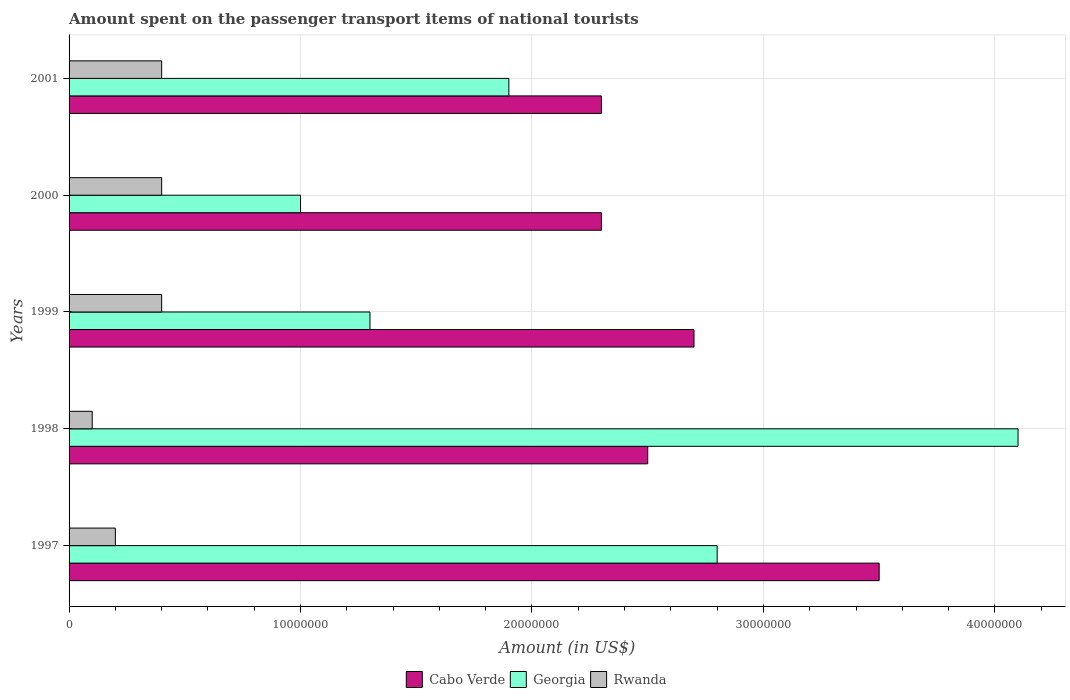Are the number of bars per tick equal to the number of legend labels?
Ensure brevity in your answer.  Yes. How many bars are there on the 4th tick from the top?
Keep it short and to the point. 3. What is the label of the 4th group of bars from the top?
Make the answer very short. 1998. In how many cases, is the number of bars for a given year not equal to the number of legend labels?
Your response must be concise. 0. What is the amount spent on the passenger transport items of national tourists in Cabo Verde in 2000?
Ensure brevity in your answer.  2.30e+07. Across all years, what is the maximum amount spent on the passenger transport items of national tourists in Rwanda?
Your response must be concise. 4.00e+06. Across all years, what is the minimum amount spent on the passenger transport items of national tourists in Georgia?
Provide a short and direct response. 1.00e+07. In which year was the amount spent on the passenger transport items of national tourists in Georgia maximum?
Your answer should be compact. 1998. In which year was the amount spent on the passenger transport items of national tourists in Rwanda minimum?
Keep it short and to the point. 1998. What is the total amount spent on the passenger transport items of national tourists in Georgia in the graph?
Your answer should be compact. 1.11e+08. What is the difference between the amount spent on the passenger transport items of national tourists in Rwanda in 1999 and that in 2001?
Offer a terse response. 0. What is the difference between the amount spent on the passenger transport items of national tourists in Cabo Verde in 2000 and the amount spent on the passenger transport items of national tourists in Georgia in 1998?
Provide a succinct answer. -1.80e+07. In the year 2000, what is the difference between the amount spent on the passenger transport items of national tourists in Georgia and amount spent on the passenger transport items of national tourists in Rwanda?
Give a very brief answer. 6.00e+06. What is the ratio of the amount spent on the passenger transport items of national tourists in Rwanda in 1997 to that in 2000?
Ensure brevity in your answer.  0.5. Is the amount spent on the passenger transport items of national tourists in Georgia in 1999 less than that in 2000?
Your response must be concise. No. Is the sum of the amount spent on the passenger transport items of national tourists in Cabo Verde in 1998 and 1999 greater than the maximum amount spent on the passenger transport items of national tourists in Georgia across all years?
Your answer should be compact. Yes. What does the 2nd bar from the top in 1997 represents?
Offer a very short reply. Georgia. What does the 1st bar from the bottom in 1997 represents?
Provide a short and direct response. Cabo Verde. Is it the case that in every year, the sum of the amount spent on the passenger transport items of national tourists in Rwanda and amount spent on the passenger transport items of national tourists in Georgia is greater than the amount spent on the passenger transport items of national tourists in Cabo Verde?
Give a very brief answer. No. Are all the bars in the graph horizontal?
Offer a very short reply. Yes. How many years are there in the graph?
Offer a very short reply. 5. Are the values on the major ticks of X-axis written in scientific E-notation?
Your answer should be compact. No. Does the graph contain grids?
Your answer should be compact. Yes. What is the title of the graph?
Your answer should be very brief. Amount spent on the passenger transport items of national tourists. What is the Amount (in US$) of Cabo Verde in 1997?
Ensure brevity in your answer.  3.50e+07. What is the Amount (in US$) of Georgia in 1997?
Provide a succinct answer. 2.80e+07. What is the Amount (in US$) in Cabo Verde in 1998?
Give a very brief answer. 2.50e+07. What is the Amount (in US$) of Georgia in 1998?
Make the answer very short. 4.10e+07. What is the Amount (in US$) in Rwanda in 1998?
Keep it short and to the point. 1.00e+06. What is the Amount (in US$) of Cabo Verde in 1999?
Your answer should be compact. 2.70e+07. What is the Amount (in US$) in Georgia in 1999?
Offer a very short reply. 1.30e+07. What is the Amount (in US$) in Rwanda in 1999?
Your answer should be very brief. 4.00e+06. What is the Amount (in US$) of Cabo Verde in 2000?
Make the answer very short. 2.30e+07. What is the Amount (in US$) of Georgia in 2000?
Keep it short and to the point. 1.00e+07. What is the Amount (in US$) in Cabo Verde in 2001?
Your answer should be very brief. 2.30e+07. What is the Amount (in US$) of Georgia in 2001?
Provide a short and direct response. 1.90e+07. Across all years, what is the maximum Amount (in US$) of Cabo Verde?
Provide a succinct answer. 3.50e+07. Across all years, what is the maximum Amount (in US$) of Georgia?
Your answer should be compact. 4.10e+07. Across all years, what is the minimum Amount (in US$) of Cabo Verde?
Your answer should be very brief. 2.30e+07. Across all years, what is the minimum Amount (in US$) in Georgia?
Give a very brief answer. 1.00e+07. What is the total Amount (in US$) of Cabo Verde in the graph?
Your response must be concise. 1.33e+08. What is the total Amount (in US$) in Georgia in the graph?
Give a very brief answer. 1.11e+08. What is the total Amount (in US$) of Rwanda in the graph?
Keep it short and to the point. 1.50e+07. What is the difference between the Amount (in US$) of Cabo Verde in 1997 and that in 1998?
Keep it short and to the point. 1.00e+07. What is the difference between the Amount (in US$) in Georgia in 1997 and that in 1998?
Keep it short and to the point. -1.30e+07. What is the difference between the Amount (in US$) in Cabo Verde in 1997 and that in 1999?
Your response must be concise. 8.00e+06. What is the difference between the Amount (in US$) of Georgia in 1997 and that in 1999?
Your answer should be very brief. 1.50e+07. What is the difference between the Amount (in US$) in Georgia in 1997 and that in 2000?
Ensure brevity in your answer.  1.80e+07. What is the difference between the Amount (in US$) in Rwanda in 1997 and that in 2000?
Provide a succinct answer. -2.00e+06. What is the difference between the Amount (in US$) in Georgia in 1997 and that in 2001?
Ensure brevity in your answer.  9.00e+06. What is the difference between the Amount (in US$) of Rwanda in 1997 and that in 2001?
Your response must be concise. -2.00e+06. What is the difference between the Amount (in US$) in Cabo Verde in 1998 and that in 1999?
Make the answer very short. -2.00e+06. What is the difference between the Amount (in US$) in Georgia in 1998 and that in 1999?
Your answer should be compact. 2.80e+07. What is the difference between the Amount (in US$) of Cabo Verde in 1998 and that in 2000?
Ensure brevity in your answer.  2.00e+06. What is the difference between the Amount (in US$) in Georgia in 1998 and that in 2000?
Give a very brief answer. 3.10e+07. What is the difference between the Amount (in US$) of Georgia in 1998 and that in 2001?
Keep it short and to the point. 2.20e+07. What is the difference between the Amount (in US$) in Rwanda in 1998 and that in 2001?
Make the answer very short. -3.00e+06. What is the difference between the Amount (in US$) of Cabo Verde in 1999 and that in 2000?
Provide a short and direct response. 4.00e+06. What is the difference between the Amount (in US$) in Georgia in 1999 and that in 2000?
Your answer should be very brief. 3.00e+06. What is the difference between the Amount (in US$) of Georgia in 1999 and that in 2001?
Your response must be concise. -6.00e+06. What is the difference between the Amount (in US$) of Georgia in 2000 and that in 2001?
Your answer should be very brief. -9.00e+06. What is the difference between the Amount (in US$) of Rwanda in 2000 and that in 2001?
Give a very brief answer. 0. What is the difference between the Amount (in US$) of Cabo Verde in 1997 and the Amount (in US$) of Georgia in 1998?
Make the answer very short. -6.00e+06. What is the difference between the Amount (in US$) of Cabo Verde in 1997 and the Amount (in US$) of Rwanda in 1998?
Your response must be concise. 3.40e+07. What is the difference between the Amount (in US$) in Georgia in 1997 and the Amount (in US$) in Rwanda in 1998?
Your answer should be very brief. 2.70e+07. What is the difference between the Amount (in US$) in Cabo Verde in 1997 and the Amount (in US$) in Georgia in 1999?
Make the answer very short. 2.20e+07. What is the difference between the Amount (in US$) in Cabo Verde in 1997 and the Amount (in US$) in Rwanda in 1999?
Offer a terse response. 3.10e+07. What is the difference between the Amount (in US$) in Georgia in 1997 and the Amount (in US$) in Rwanda in 1999?
Offer a very short reply. 2.40e+07. What is the difference between the Amount (in US$) in Cabo Verde in 1997 and the Amount (in US$) in Georgia in 2000?
Your response must be concise. 2.50e+07. What is the difference between the Amount (in US$) of Cabo Verde in 1997 and the Amount (in US$) of Rwanda in 2000?
Give a very brief answer. 3.10e+07. What is the difference between the Amount (in US$) of Georgia in 1997 and the Amount (in US$) of Rwanda in 2000?
Give a very brief answer. 2.40e+07. What is the difference between the Amount (in US$) in Cabo Verde in 1997 and the Amount (in US$) in Georgia in 2001?
Keep it short and to the point. 1.60e+07. What is the difference between the Amount (in US$) of Cabo Verde in 1997 and the Amount (in US$) of Rwanda in 2001?
Give a very brief answer. 3.10e+07. What is the difference between the Amount (in US$) of Georgia in 1997 and the Amount (in US$) of Rwanda in 2001?
Your answer should be compact. 2.40e+07. What is the difference between the Amount (in US$) of Cabo Verde in 1998 and the Amount (in US$) of Georgia in 1999?
Your answer should be very brief. 1.20e+07. What is the difference between the Amount (in US$) of Cabo Verde in 1998 and the Amount (in US$) of Rwanda in 1999?
Offer a very short reply. 2.10e+07. What is the difference between the Amount (in US$) of Georgia in 1998 and the Amount (in US$) of Rwanda in 1999?
Give a very brief answer. 3.70e+07. What is the difference between the Amount (in US$) in Cabo Verde in 1998 and the Amount (in US$) in Georgia in 2000?
Keep it short and to the point. 1.50e+07. What is the difference between the Amount (in US$) of Cabo Verde in 1998 and the Amount (in US$) of Rwanda in 2000?
Give a very brief answer. 2.10e+07. What is the difference between the Amount (in US$) of Georgia in 1998 and the Amount (in US$) of Rwanda in 2000?
Make the answer very short. 3.70e+07. What is the difference between the Amount (in US$) in Cabo Verde in 1998 and the Amount (in US$) in Rwanda in 2001?
Your response must be concise. 2.10e+07. What is the difference between the Amount (in US$) of Georgia in 1998 and the Amount (in US$) of Rwanda in 2001?
Give a very brief answer. 3.70e+07. What is the difference between the Amount (in US$) of Cabo Verde in 1999 and the Amount (in US$) of Georgia in 2000?
Offer a terse response. 1.70e+07. What is the difference between the Amount (in US$) in Cabo Verde in 1999 and the Amount (in US$) in Rwanda in 2000?
Ensure brevity in your answer.  2.30e+07. What is the difference between the Amount (in US$) in Georgia in 1999 and the Amount (in US$) in Rwanda in 2000?
Keep it short and to the point. 9.00e+06. What is the difference between the Amount (in US$) of Cabo Verde in 1999 and the Amount (in US$) of Georgia in 2001?
Offer a very short reply. 8.00e+06. What is the difference between the Amount (in US$) in Cabo Verde in 1999 and the Amount (in US$) in Rwanda in 2001?
Give a very brief answer. 2.30e+07. What is the difference between the Amount (in US$) in Georgia in 1999 and the Amount (in US$) in Rwanda in 2001?
Offer a terse response. 9.00e+06. What is the difference between the Amount (in US$) of Cabo Verde in 2000 and the Amount (in US$) of Georgia in 2001?
Your answer should be compact. 4.00e+06. What is the difference between the Amount (in US$) of Cabo Verde in 2000 and the Amount (in US$) of Rwanda in 2001?
Provide a succinct answer. 1.90e+07. What is the difference between the Amount (in US$) of Georgia in 2000 and the Amount (in US$) of Rwanda in 2001?
Provide a short and direct response. 6.00e+06. What is the average Amount (in US$) in Cabo Verde per year?
Ensure brevity in your answer.  2.66e+07. What is the average Amount (in US$) in Georgia per year?
Your answer should be compact. 2.22e+07. In the year 1997, what is the difference between the Amount (in US$) of Cabo Verde and Amount (in US$) of Rwanda?
Ensure brevity in your answer.  3.30e+07. In the year 1997, what is the difference between the Amount (in US$) of Georgia and Amount (in US$) of Rwanda?
Keep it short and to the point. 2.60e+07. In the year 1998, what is the difference between the Amount (in US$) in Cabo Verde and Amount (in US$) in Georgia?
Ensure brevity in your answer.  -1.60e+07. In the year 1998, what is the difference between the Amount (in US$) in Cabo Verde and Amount (in US$) in Rwanda?
Your answer should be compact. 2.40e+07. In the year 1998, what is the difference between the Amount (in US$) of Georgia and Amount (in US$) of Rwanda?
Offer a terse response. 4.00e+07. In the year 1999, what is the difference between the Amount (in US$) of Cabo Verde and Amount (in US$) of Georgia?
Your answer should be very brief. 1.40e+07. In the year 1999, what is the difference between the Amount (in US$) in Cabo Verde and Amount (in US$) in Rwanda?
Provide a succinct answer. 2.30e+07. In the year 1999, what is the difference between the Amount (in US$) in Georgia and Amount (in US$) in Rwanda?
Your answer should be very brief. 9.00e+06. In the year 2000, what is the difference between the Amount (in US$) in Cabo Verde and Amount (in US$) in Georgia?
Give a very brief answer. 1.30e+07. In the year 2000, what is the difference between the Amount (in US$) in Cabo Verde and Amount (in US$) in Rwanda?
Ensure brevity in your answer.  1.90e+07. In the year 2000, what is the difference between the Amount (in US$) in Georgia and Amount (in US$) in Rwanda?
Make the answer very short. 6.00e+06. In the year 2001, what is the difference between the Amount (in US$) in Cabo Verde and Amount (in US$) in Georgia?
Offer a terse response. 4.00e+06. In the year 2001, what is the difference between the Amount (in US$) of Cabo Verde and Amount (in US$) of Rwanda?
Keep it short and to the point. 1.90e+07. In the year 2001, what is the difference between the Amount (in US$) of Georgia and Amount (in US$) of Rwanda?
Your response must be concise. 1.50e+07. What is the ratio of the Amount (in US$) in Cabo Verde in 1997 to that in 1998?
Make the answer very short. 1.4. What is the ratio of the Amount (in US$) in Georgia in 1997 to that in 1998?
Provide a short and direct response. 0.68. What is the ratio of the Amount (in US$) of Rwanda in 1997 to that in 1998?
Make the answer very short. 2. What is the ratio of the Amount (in US$) in Cabo Verde in 1997 to that in 1999?
Your answer should be very brief. 1.3. What is the ratio of the Amount (in US$) in Georgia in 1997 to that in 1999?
Give a very brief answer. 2.15. What is the ratio of the Amount (in US$) of Rwanda in 1997 to that in 1999?
Provide a short and direct response. 0.5. What is the ratio of the Amount (in US$) in Cabo Verde in 1997 to that in 2000?
Keep it short and to the point. 1.52. What is the ratio of the Amount (in US$) in Cabo Verde in 1997 to that in 2001?
Offer a terse response. 1.52. What is the ratio of the Amount (in US$) in Georgia in 1997 to that in 2001?
Your answer should be very brief. 1.47. What is the ratio of the Amount (in US$) in Cabo Verde in 1998 to that in 1999?
Make the answer very short. 0.93. What is the ratio of the Amount (in US$) of Georgia in 1998 to that in 1999?
Offer a very short reply. 3.15. What is the ratio of the Amount (in US$) in Rwanda in 1998 to that in 1999?
Your answer should be compact. 0.25. What is the ratio of the Amount (in US$) of Cabo Verde in 1998 to that in 2000?
Keep it short and to the point. 1.09. What is the ratio of the Amount (in US$) of Georgia in 1998 to that in 2000?
Keep it short and to the point. 4.1. What is the ratio of the Amount (in US$) of Cabo Verde in 1998 to that in 2001?
Offer a very short reply. 1.09. What is the ratio of the Amount (in US$) of Georgia in 1998 to that in 2001?
Your answer should be compact. 2.16. What is the ratio of the Amount (in US$) in Rwanda in 1998 to that in 2001?
Give a very brief answer. 0.25. What is the ratio of the Amount (in US$) in Cabo Verde in 1999 to that in 2000?
Offer a very short reply. 1.17. What is the ratio of the Amount (in US$) in Georgia in 1999 to that in 2000?
Offer a very short reply. 1.3. What is the ratio of the Amount (in US$) in Cabo Verde in 1999 to that in 2001?
Your answer should be very brief. 1.17. What is the ratio of the Amount (in US$) of Georgia in 1999 to that in 2001?
Your response must be concise. 0.68. What is the ratio of the Amount (in US$) of Rwanda in 1999 to that in 2001?
Keep it short and to the point. 1. What is the ratio of the Amount (in US$) of Cabo Verde in 2000 to that in 2001?
Your answer should be compact. 1. What is the ratio of the Amount (in US$) of Georgia in 2000 to that in 2001?
Make the answer very short. 0.53. What is the ratio of the Amount (in US$) in Rwanda in 2000 to that in 2001?
Provide a succinct answer. 1. What is the difference between the highest and the second highest Amount (in US$) in Georgia?
Provide a succinct answer. 1.30e+07. What is the difference between the highest and the second highest Amount (in US$) in Rwanda?
Give a very brief answer. 0. What is the difference between the highest and the lowest Amount (in US$) of Georgia?
Keep it short and to the point. 3.10e+07. What is the difference between the highest and the lowest Amount (in US$) of Rwanda?
Provide a succinct answer. 3.00e+06. 